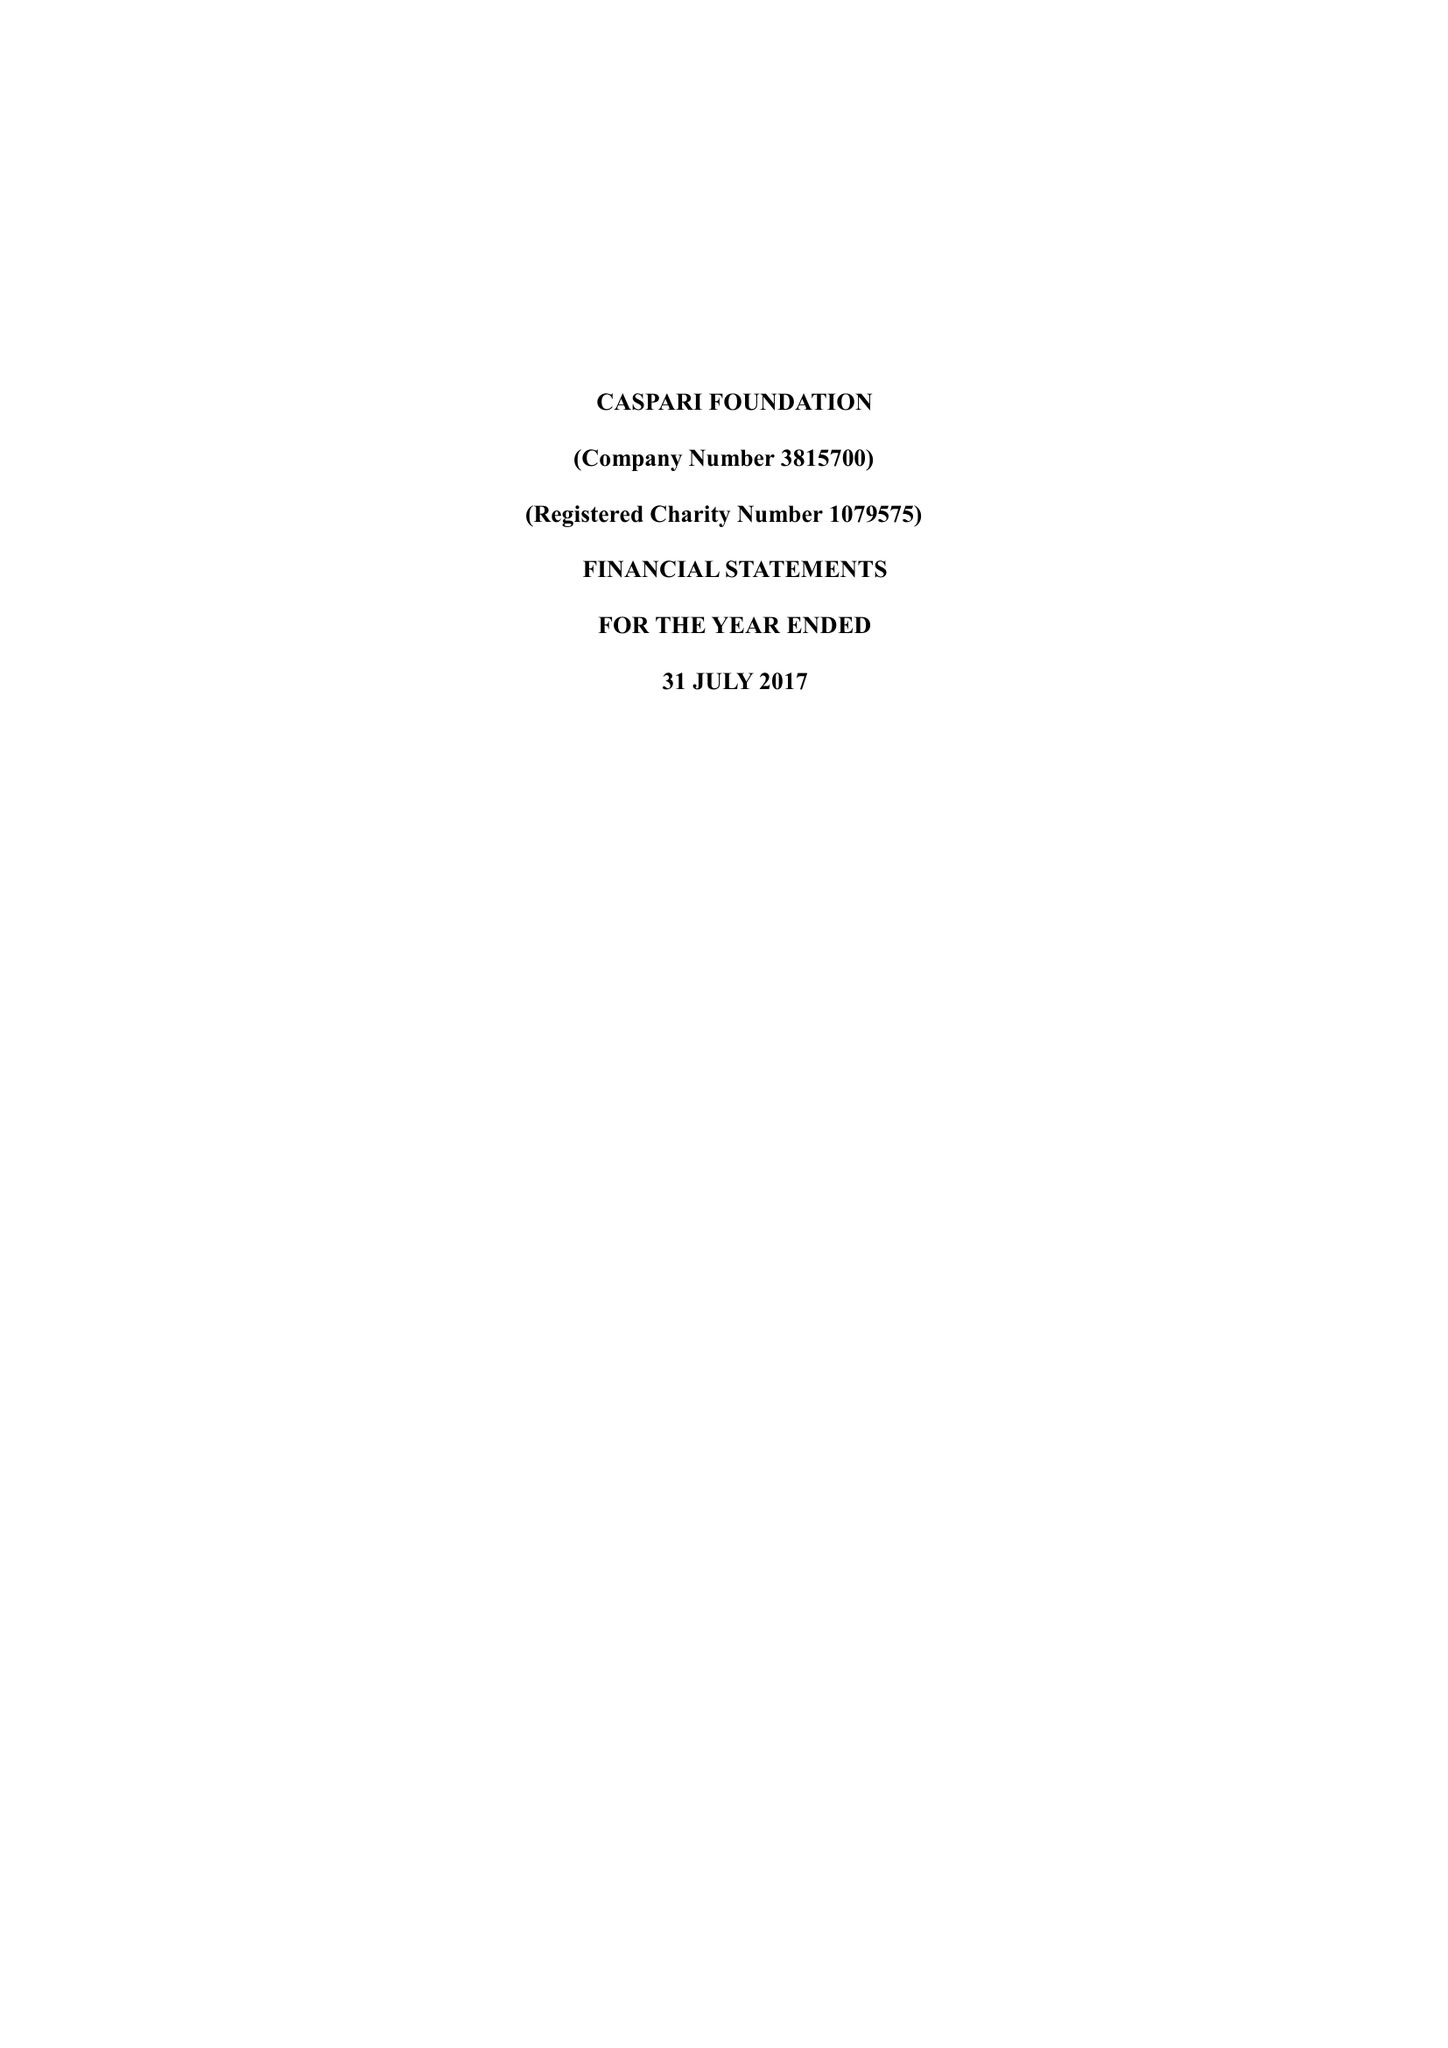What is the value for the charity_name?
Answer the question using a single word or phrase. Caspari Foundation 